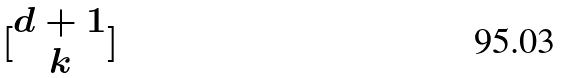<formula> <loc_0><loc_0><loc_500><loc_500>[ \begin{matrix} d + 1 \\ k \end{matrix} ]</formula> 